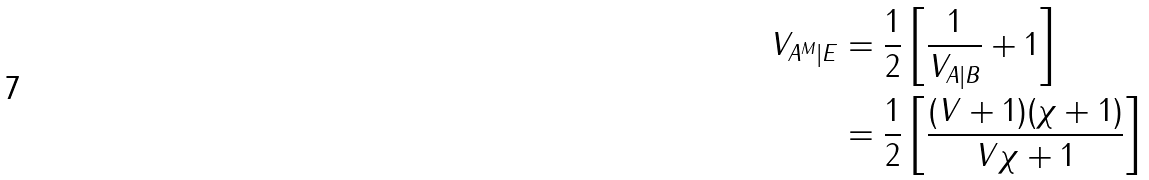<formula> <loc_0><loc_0><loc_500><loc_500>V _ { A ^ { M } | E } & = \frac { 1 } { 2 } \left [ \frac { 1 } { V _ { A | B } } + 1 \right ] \\ & = \frac { 1 } { 2 } \left [ \frac { ( V + 1 ) ( \chi + 1 ) } { V \chi + 1 } \right ]</formula> 